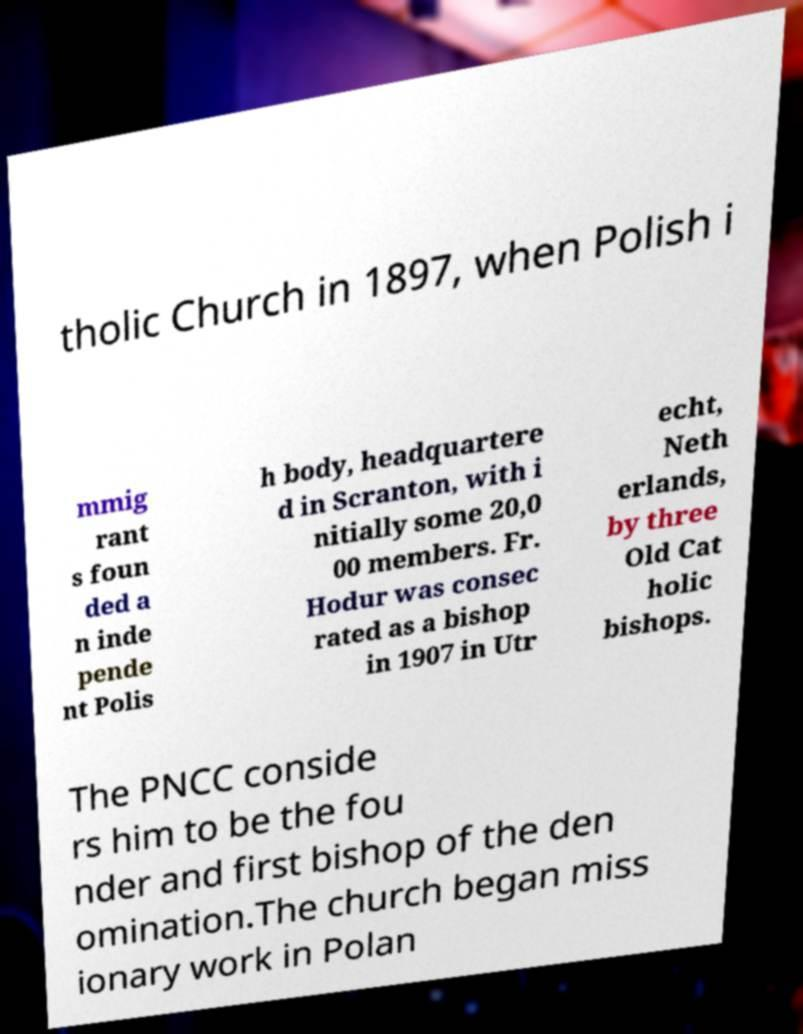I need the written content from this picture converted into text. Can you do that? tholic Church in 1897, when Polish i mmig rant s foun ded a n inde pende nt Polis h body, headquartere d in Scranton, with i nitially some 20,0 00 members. Fr. Hodur was consec rated as a bishop in 1907 in Utr echt, Neth erlands, by three Old Cat holic bishops. The PNCC conside rs him to be the fou nder and first bishop of the den omination.The church began miss ionary work in Polan 